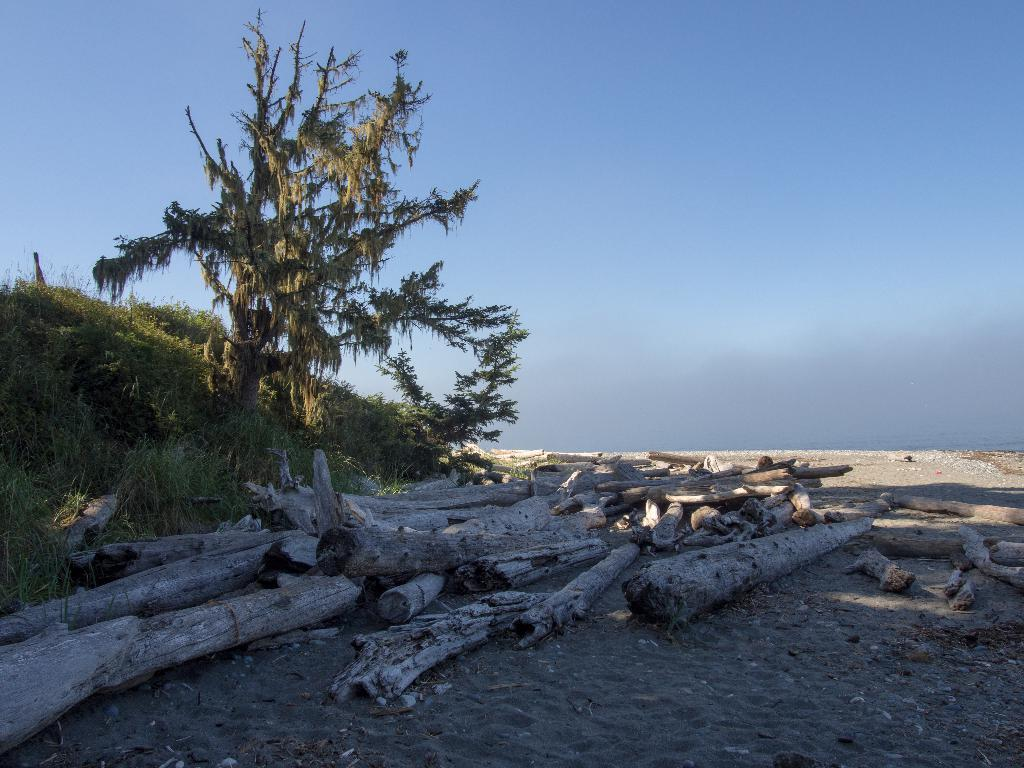What type of plant can be seen in the image? There is a tree in the image. What other vegetation is present in the image? There are bushes in the image. What material are the trunks made of in the image? The wooden trunks in the image are made of wood. What can be seen in the background of the image? The sky is visible in the image. How many chairs are placed on the stage in the image? There are no chairs or stage present in the image. 